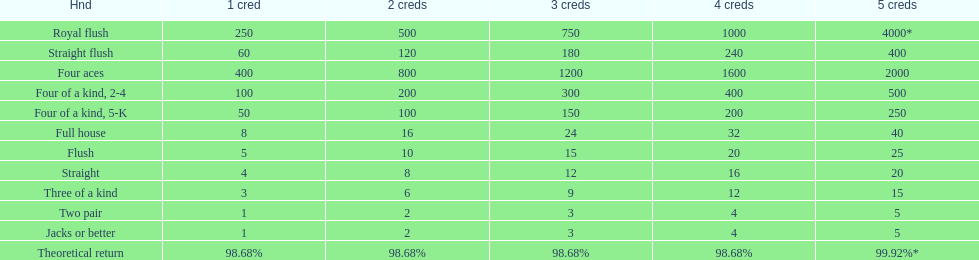What's the best type of four of a kind to win? Four of a kind, 2-4. 